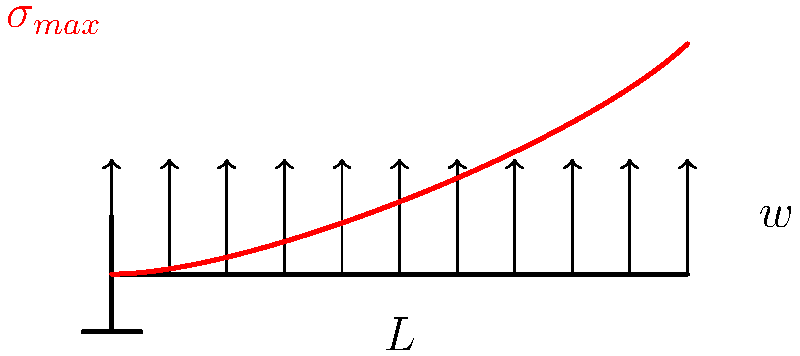In your latest Hellboy-inspired art installation, you've designed a cantilever beam to support a heavy prop. The beam has length $L$ and is subjected to a uniformly distributed load $w$. If the beam has a rectangular cross-section with width $b$ and height $h$, what is the maximum bending stress $\sigma_{max}$ at the fixed end in terms of $w$, $L$, $b$, and $h$? To find the maximum bending stress in the cantilever beam, we'll follow these steps:

1. Determine the maximum bending moment:
   For a cantilever beam with uniformly distributed load $w$, the maximum bending moment occurs at the fixed end:
   $$M_{max} = \frac{wL^2}{2}$$

2. Calculate the moment of inertia for a rectangular cross-section:
   $$I = \frac{bh^3}{12}$$

3. Find the distance from the neutral axis to the outermost fiber:
   $$y = \frac{h}{2}$$

4. Apply the flexure formula to calculate the maximum bending stress:
   $$\sigma_{max} = \frac{M_{max}y}{I}$$

5. Substitute the expressions for $M_{max}$, $y$, and $I$:
   $$\sigma_{max} = \frac{(\frac{wL^2}{2})(\frac{h}{2})}{(\frac{bh^3}{12})}$$

6. Simplify the expression:
   $$\sigma_{max} = \frac{6wL^2}{bh^2}$$

This final expression gives the maximum bending stress at the fixed end of the cantilever beam in terms of the given parameters.
Answer: $\sigma_{max} = \frac{6wL^2}{bh^2}$ 